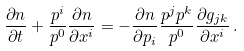Convert formula to latex. <formula><loc_0><loc_0><loc_500><loc_500>\frac { \partial n } { \partial t } + \frac { p ^ { i } } { p ^ { 0 } } \frac { \partial n } { \partial x ^ { i } } = - \frac { \partial n } { \partial p _ { i } } \frac { p ^ { j } p ^ { k } } { p ^ { 0 } } \frac { \partial g _ { j k } } { \partial x ^ { i } } \, .</formula> 